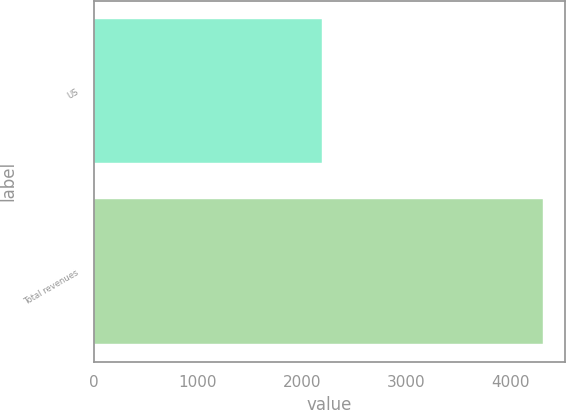Convert chart to OTSL. <chart><loc_0><loc_0><loc_500><loc_500><bar_chart><fcel>US<fcel>Total revenues<nl><fcel>2189.7<fcel>4313.1<nl></chart> 